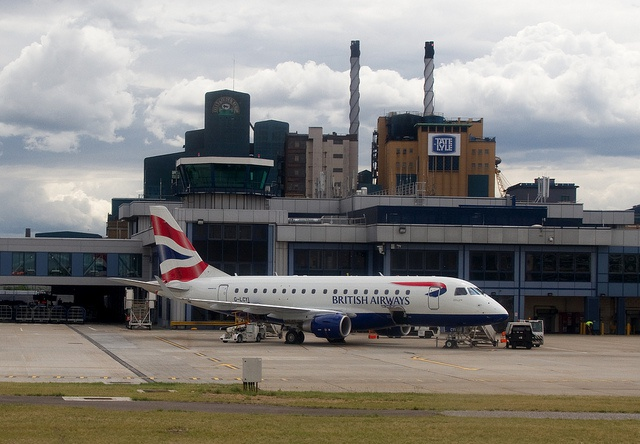Describe the objects in this image and their specific colors. I can see airplane in darkgray, black, gray, and lightgray tones, truck in darkgray, gray, and black tones, truck in darkgray, black, and gray tones, truck in darkgray, black, and gray tones, and people in darkgray, black, darkgreen, and olive tones in this image. 